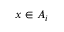Convert formula to latex. <formula><loc_0><loc_0><loc_500><loc_500>x \in A _ { i }</formula> 